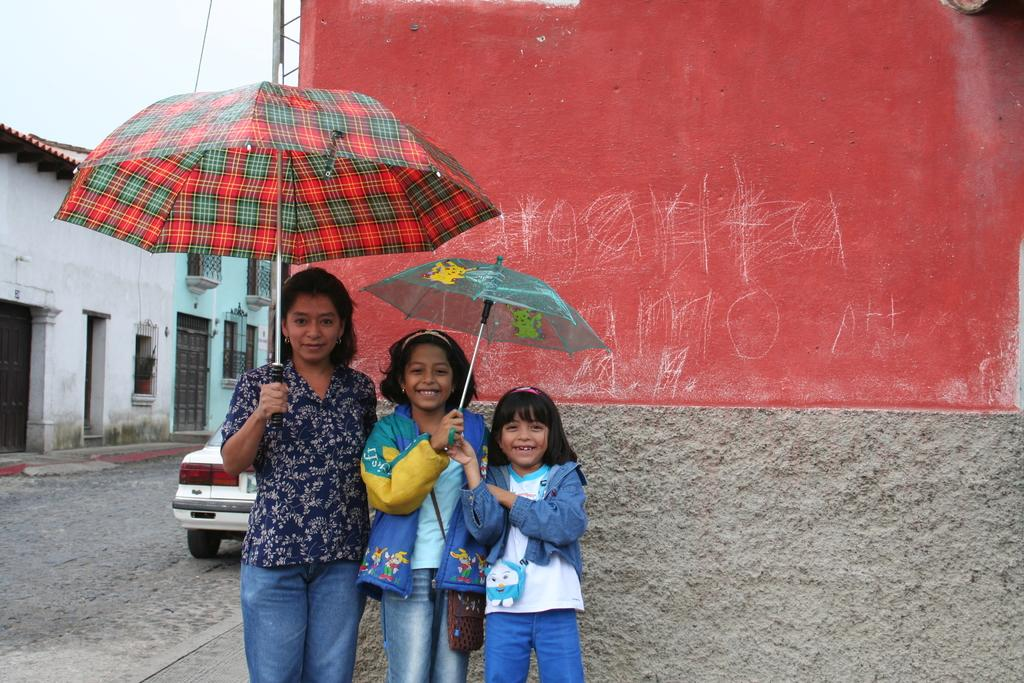What are the people in the image doing? The people in the image are standing and holding an umbrella. What can be seen in the background of the image? There is a wall in the background of the image. How many houses are visible on the left side of the image? There are two houses on the left side of the image. What type of vehicle is present on the road in the image? There is a car on the road in the road in the image. What type of fruit is being served on a plate in the image? There is no plate or fruit present in the image. What color is the tail of the animal in the image? A: There is no animal or tail present in the image. 